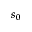Convert formula to latex. <formula><loc_0><loc_0><loc_500><loc_500>s _ { 0 }</formula> 